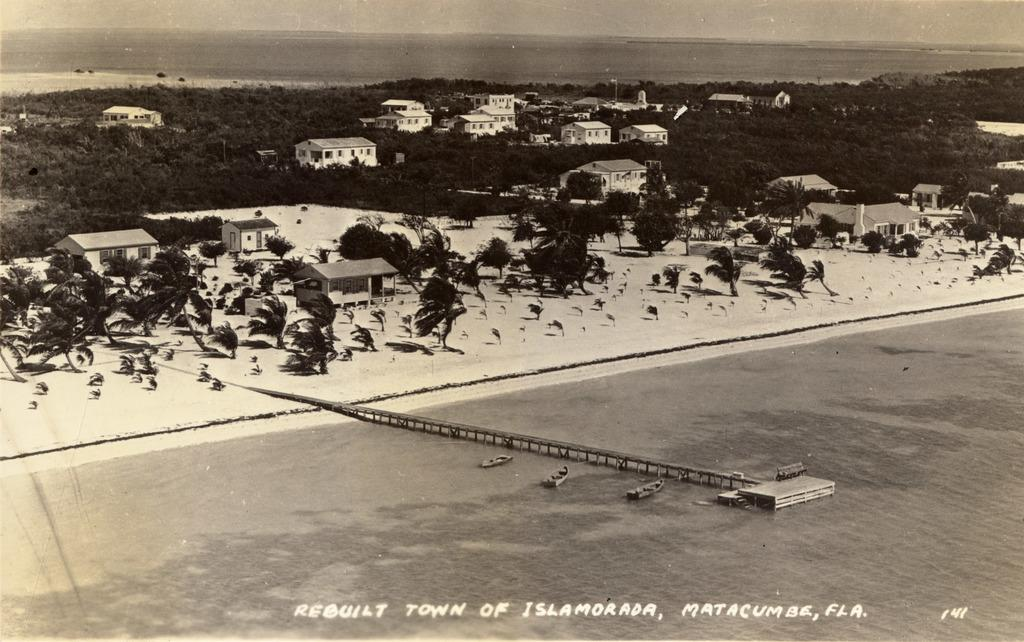Provide a one-sentence caption for the provided image. An aerial image of Islamorada, Florida is shown in black and white. 